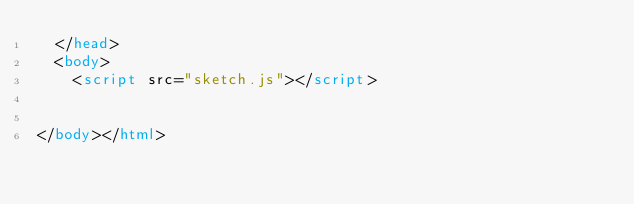Convert code to text. <code><loc_0><loc_0><loc_500><loc_500><_HTML_>  </head>
  <body>
    <script src="sketch.js"></script>
  

</body></html></code> 